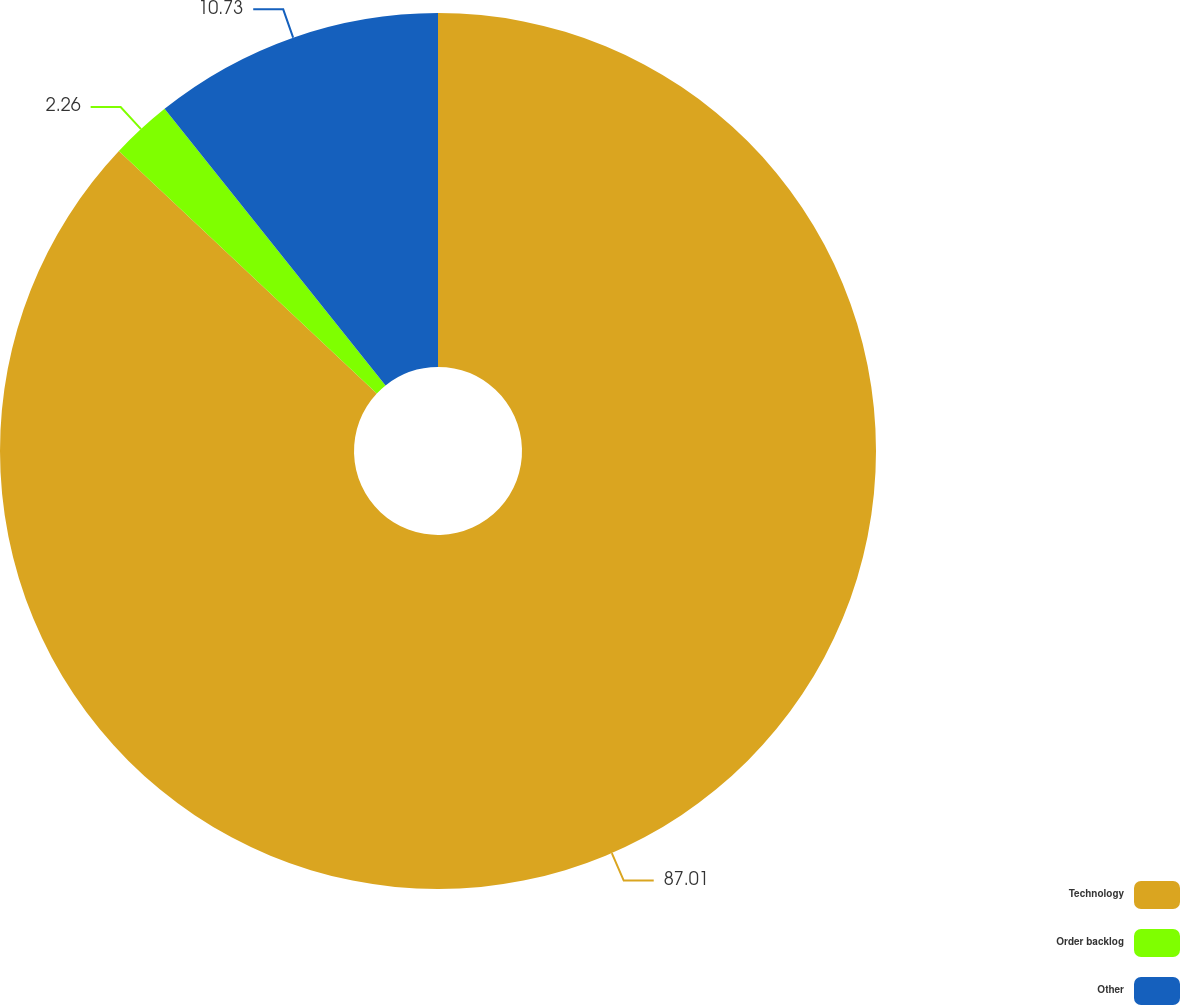Convert chart. <chart><loc_0><loc_0><loc_500><loc_500><pie_chart><fcel>Technology<fcel>Order backlog<fcel>Other<nl><fcel>87.01%<fcel>2.26%<fcel>10.73%<nl></chart> 